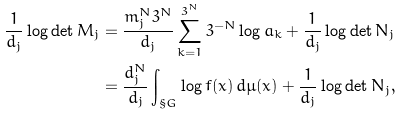<formula> <loc_0><loc_0><loc_500><loc_500>\frac { 1 } { d _ { j } } \log \det M _ { j } & = \frac { m _ { j } ^ { N } 3 ^ { N } } { d _ { j } } \sum _ { k = 1 } ^ { 3 ^ { N } } 3 ^ { - N } \log a _ { k } + \frac { 1 } { d _ { j } } \log \det N _ { j } \\ & = \frac { d ^ { N } _ { j } } { d _ { j } } \int _ { \S G } \log f ( x ) \, d \mu ( x ) + \frac { 1 } { d _ { j } } \log \det N _ { j } ,</formula> 